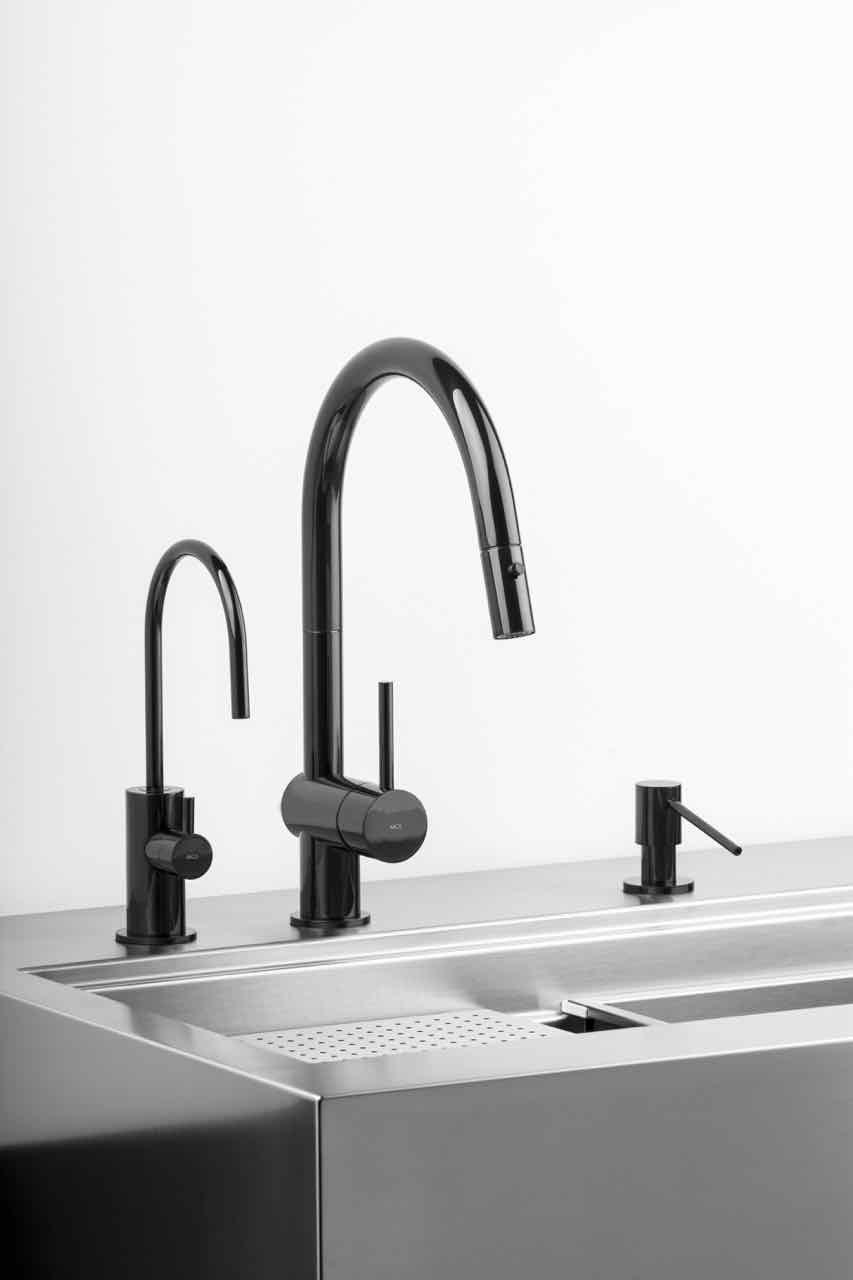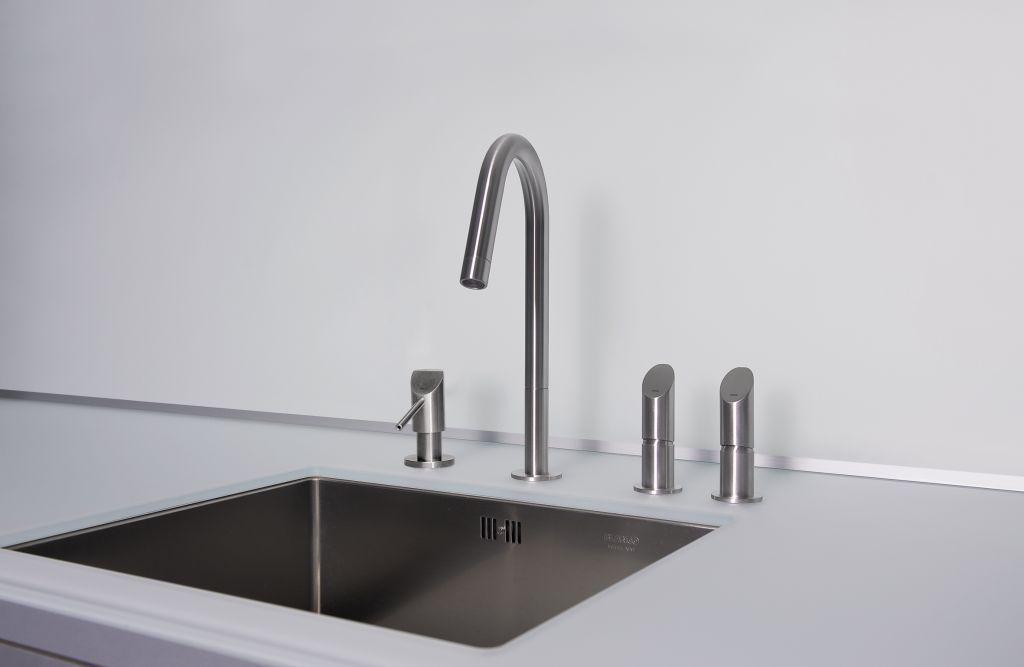The first image is the image on the left, the second image is the image on the right. For the images displayed, is the sentence "An image includes a single chrome spout that curves downward." factually correct? Answer yes or no. Yes. The first image is the image on the left, the second image is the image on the right. Evaluate the accuracy of this statement regarding the images: "A built-in soap dispenser is next to a faucet in at least one of the images.". Is it true? Answer yes or no. Yes. 